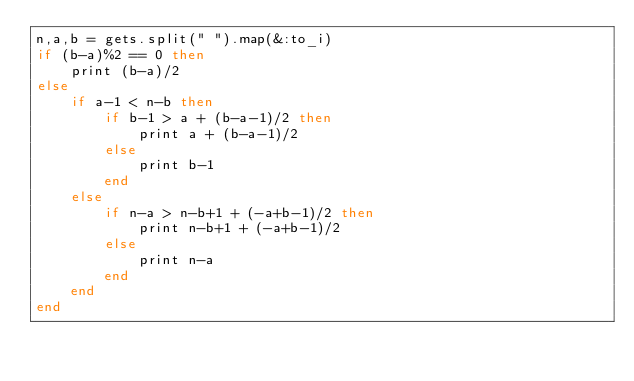<code> <loc_0><loc_0><loc_500><loc_500><_Ruby_>n,a,b = gets.split(" ").map(&:to_i)
if (b-a)%2 == 0 then
    print (b-a)/2
else
    if a-1 < n-b then
        if b-1 > a + (b-a-1)/2 then
            print a + (b-a-1)/2
        else
            print b-1
        end
    else
        if n-a > n-b+1 + (-a+b-1)/2 then
            print n-b+1 + (-a+b-1)/2
        else
            print n-a
        end
    end
end</code> 